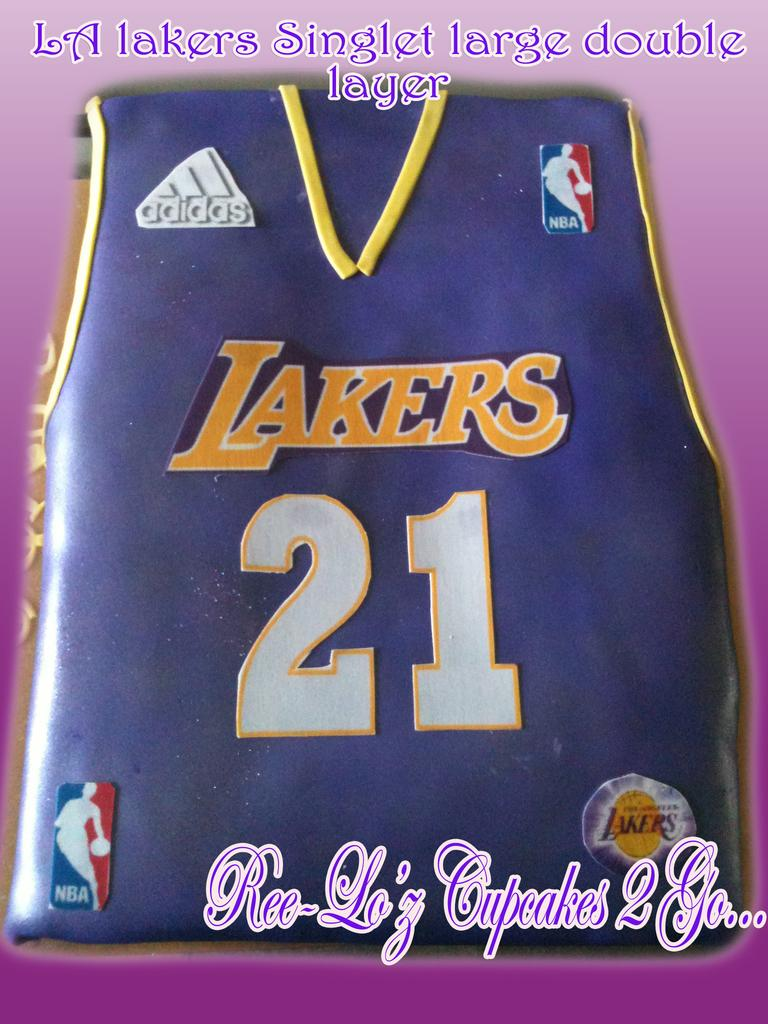<image>
Summarize the visual content of the image. Cake that looks like a jersey with the number 21 on it. 